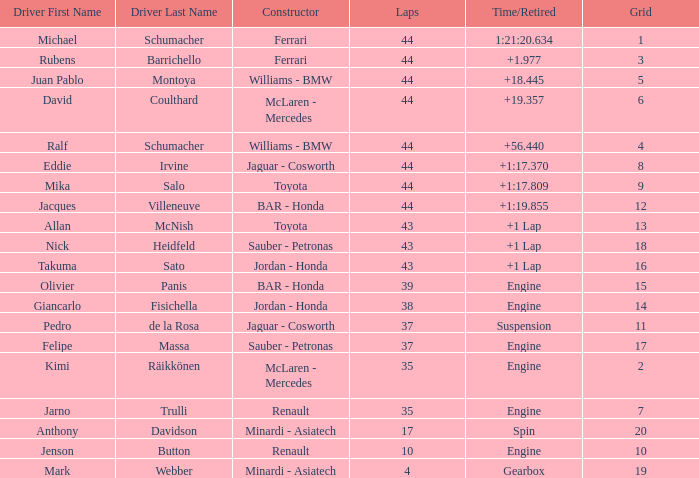What was the time of the driver on grid 3? 1.977. 